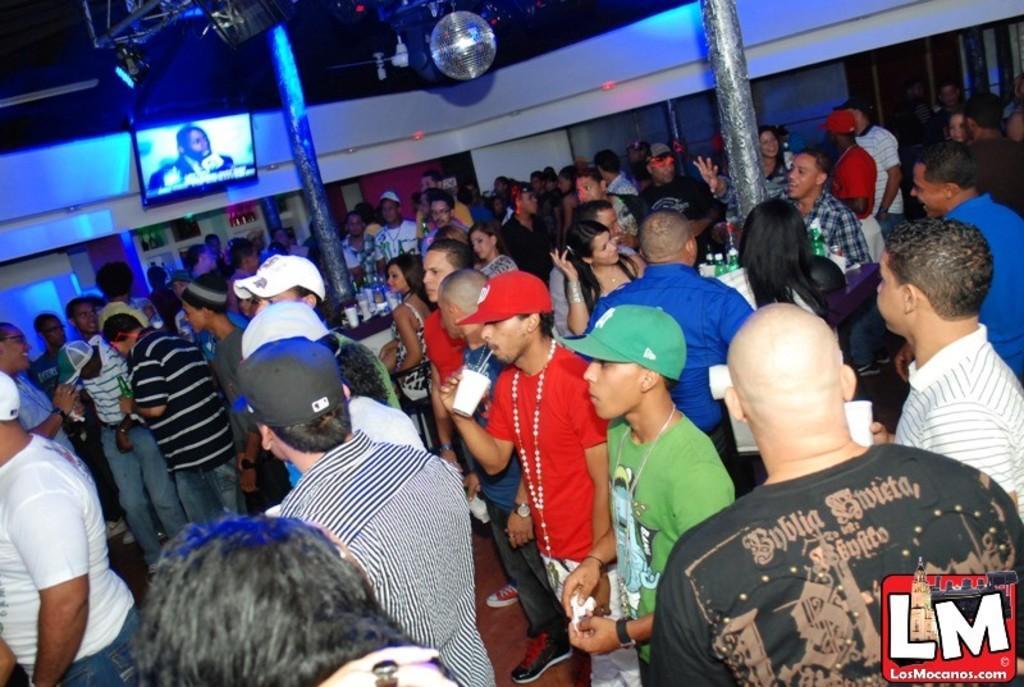Describe this image in one or two sentences. Here we can see group of people standing on the floor and among them few are holding cups in their hands. In the background there are pillars,TV on the wall,poles,lights and some other items. 